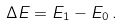Convert formula to latex. <formula><loc_0><loc_0><loc_500><loc_500>\Delta E = E _ { 1 } - E _ { 0 } \, .</formula> 